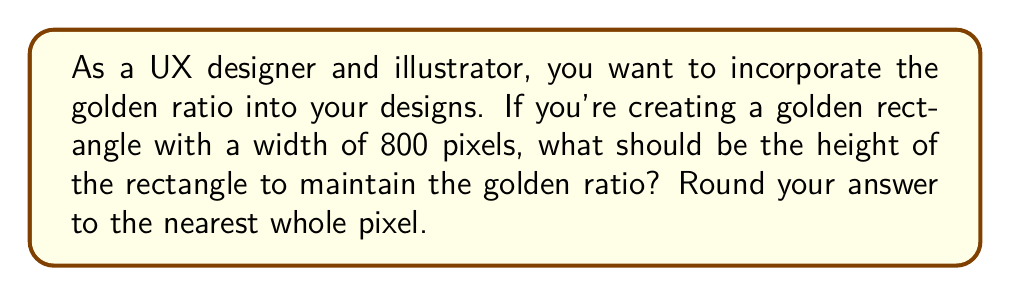Could you help me with this problem? To solve this problem, we need to understand the golden ratio and how it applies to rectangles. The golden ratio, denoted by φ (phi), is approximately 1.618033988749895.

For a golden rectangle, the ratio of the longer side to the shorter side is equal to φ. In this case, we know the width is 800 pixels, so we need to find the height.

Let's set up the equation:

$$ \frac{\text{longer side}}{\text{shorter side}} = φ $$

Since the width is given as 800 pixels, we assume it's the longer side:

$$ \frac{800}{\text{height}} = φ $$

To solve for the height, we can cross-multiply:

$$ \text{height} * φ = 800 $$

$$ \text{height} = \frac{800}{φ} $$

Now, let's calculate:

$$ \text{height} = \frac{800}{1.618033988749895} ≈ 494.427190999916 $$

Rounding to the nearest whole pixel:

$$ \text{height} ≈ 494 \text{ pixels} $$

To verify, we can check the ratio:

$$ \frac{800}{494} ≈ 1.619433198380567 $$

This is very close to φ, confirming our calculation is correct.

[asy]
size(200,124);
draw((0,0)--(200,0)--(200,124)--(0,124)--cycle);
label("800 px", (100,0), S);
label("494 px", (200,62), E);
[/asy]
Answer: The height of the golden rectangle should be 494 pixels. 